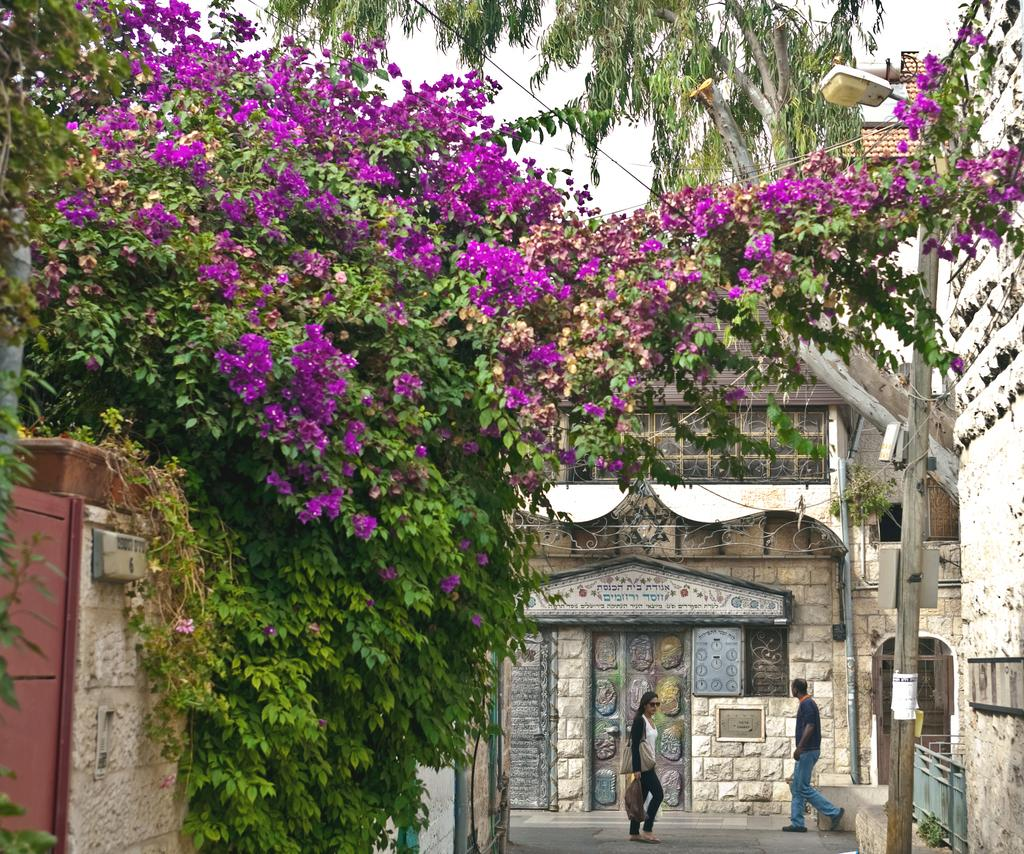How many people are present in the image? There is in the image. What are the man and woman doing in the image? Both the man and woman are walking on the road in the image. What can be seen in the background of the image? There are trees, a pole, a light, buildings with windows, and the sky visible in the background of the image. What type of jam is being spread on the boats in the image? There are no boats or jam present in the image; it features a man and woman walking on the road with various background elements. 